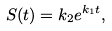Convert formula to latex. <formula><loc_0><loc_0><loc_500><loc_500>S ( t ) = k _ { 2 } e ^ { k _ { 1 } t } ,</formula> 